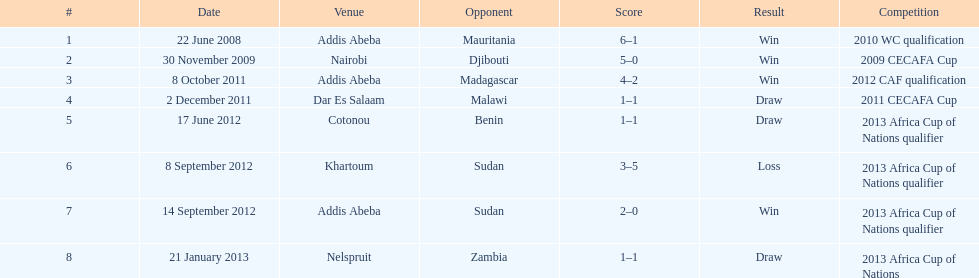Can you give me this table as a dict? {'header': ['#', 'Date', 'Venue', 'Opponent', 'Score', 'Result', 'Competition'], 'rows': [['1', '22 June 2008', 'Addis Abeba', 'Mauritania', '6–1', 'Win', '2010 WC qualification'], ['2', '30 November 2009', 'Nairobi', 'Djibouti', '5–0', 'Win', '2009 CECAFA Cup'], ['3', '8 October 2011', 'Addis Abeba', 'Madagascar', '4–2', 'Win', '2012 CAF qualification'], ['4', '2 December 2011', 'Dar Es Salaam', 'Malawi', '1–1', 'Draw', '2011 CECAFA Cup'], ['5', '17 June 2012', 'Cotonou', 'Benin', '1–1', 'Draw', '2013 Africa Cup of Nations qualifier'], ['6', '8 September 2012', 'Khartoum', 'Sudan', '3–5', 'Loss', '2013 Africa Cup of Nations qualifier'], ['7', '14 September 2012', 'Addis Abeba', 'Sudan', '2–0', 'Win', '2013 Africa Cup of Nations qualifier'], ['8', '21 January 2013', 'Nelspruit', 'Zambia', '1–1', 'Draw', '2013 Africa Cup of Nations']]} True or false? in comparison, the ethiopian national team has more draws than wins. False. 